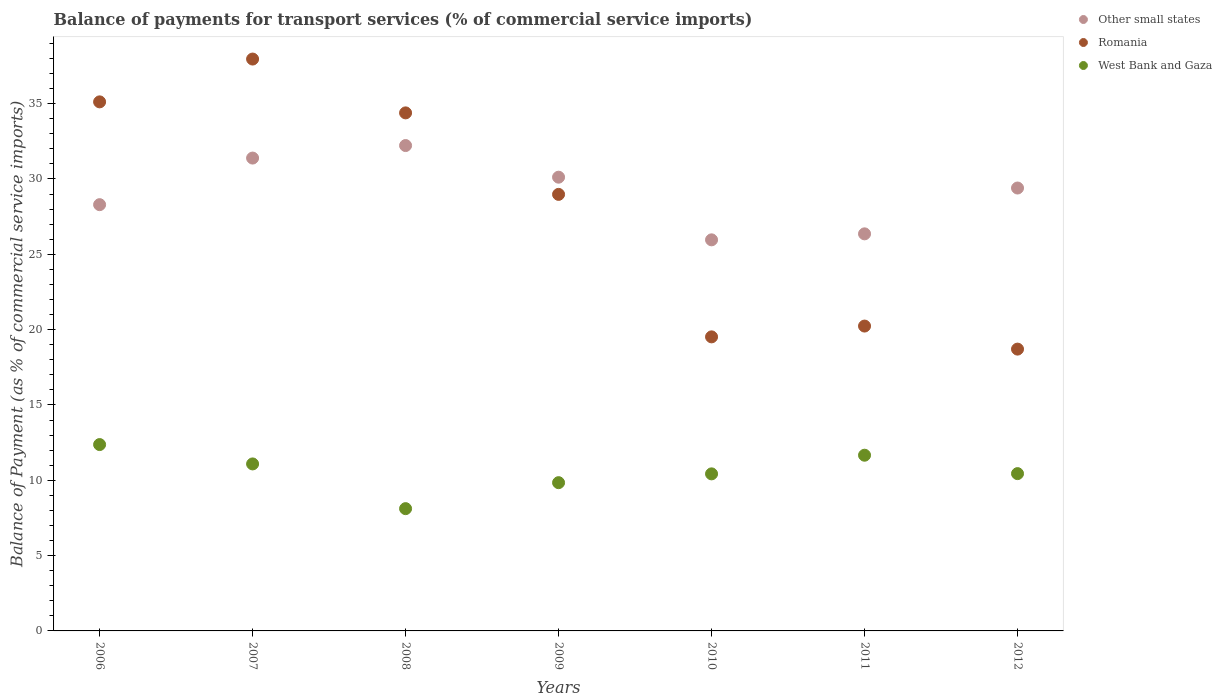How many different coloured dotlines are there?
Keep it short and to the point. 3. Is the number of dotlines equal to the number of legend labels?
Your answer should be very brief. Yes. What is the balance of payments for transport services in Other small states in 2010?
Offer a terse response. 25.96. Across all years, what is the maximum balance of payments for transport services in Romania?
Provide a short and direct response. 37.96. Across all years, what is the minimum balance of payments for transport services in West Bank and Gaza?
Offer a terse response. 8.12. In which year was the balance of payments for transport services in Other small states maximum?
Keep it short and to the point. 2008. What is the total balance of payments for transport services in West Bank and Gaza in the graph?
Give a very brief answer. 73.94. What is the difference between the balance of payments for transport services in Romania in 2007 and that in 2009?
Offer a terse response. 8.98. What is the difference between the balance of payments for transport services in Other small states in 2007 and the balance of payments for transport services in Romania in 2008?
Offer a very short reply. -3. What is the average balance of payments for transport services in West Bank and Gaza per year?
Give a very brief answer. 10.56. In the year 2010, what is the difference between the balance of payments for transport services in Other small states and balance of payments for transport services in West Bank and Gaza?
Your response must be concise. 15.53. In how many years, is the balance of payments for transport services in Romania greater than 9 %?
Your response must be concise. 7. What is the ratio of the balance of payments for transport services in West Bank and Gaza in 2007 to that in 2010?
Make the answer very short. 1.06. What is the difference between the highest and the second highest balance of payments for transport services in Other small states?
Provide a succinct answer. 0.83. What is the difference between the highest and the lowest balance of payments for transport services in Romania?
Ensure brevity in your answer.  19.25. In how many years, is the balance of payments for transport services in Romania greater than the average balance of payments for transport services in Romania taken over all years?
Your answer should be very brief. 4. Is it the case that in every year, the sum of the balance of payments for transport services in Other small states and balance of payments for transport services in West Bank and Gaza  is greater than the balance of payments for transport services in Romania?
Your response must be concise. Yes. Does the balance of payments for transport services in Other small states monotonically increase over the years?
Your answer should be very brief. No. How many dotlines are there?
Your response must be concise. 3. Does the graph contain any zero values?
Your answer should be very brief. No. What is the title of the graph?
Your answer should be compact. Balance of payments for transport services (% of commercial service imports). Does "Turkey" appear as one of the legend labels in the graph?
Provide a succinct answer. No. What is the label or title of the X-axis?
Keep it short and to the point. Years. What is the label or title of the Y-axis?
Make the answer very short. Balance of Payment (as % of commercial service imports). What is the Balance of Payment (as % of commercial service imports) of Other small states in 2006?
Offer a very short reply. 28.3. What is the Balance of Payment (as % of commercial service imports) of Romania in 2006?
Give a very brief answer. 35.12. What is the Balance of Payment (as % of commercial service imports) in West Bank and Gaza in 2006?
Your answer should be very brief. 12.37. What is the Balance of Payment (as % of commercial service imports) in Other small states in 2007?
Make the answer very short. 31.39. What is the Balance of Payment (as % of commercial service imports) in Romania in 2007?
Offer a terse response. 37.96. What is the Balance of Payment (as % of commercial service imports) of West Bank and Gaza in 2007?
Provide a short and direct response. 11.09. What is the Balance of Payment (as % of commercial service imports) of Other small states in 2008?
Your response must be concise. 32.22. What is the Balance of Payment (as % of commercial service imports) of Romania in 2008?
Keep it short and to the point. 34.39. What is the Balance of Payment (as % of commercial service imports) in West Bank and Gaza in 2008?
Your answer should be very brief. 8.12. What is the Balance of Payment (as % of commercial service imports) of Other small states in 2009?
Give a very brief answer. 30.12. What is the Balance of Payment (as % of commercial service imports) of Romania in 2009?
Your answer should be very brief. 28.98. What is the Balance of Payment (as % of commercial service imports) in West Bank and Gaza in 2009?
Give a very brief answer. 9.84. What is the Balance of Payment (as % of commercial service imports) of Other small states in 2010?
Keep it short and to the point. 25.96. What is the Balance of Payment (as % of commercial service imports) in Romania in 2010?
Offer a very short reply. 19.52. What is the Balance of Payment (as % of commercial service imports) of West Bank and Gaza in 2010?
Make the answer very short. 10.43. What is the Balance of Payment (as % of commercial service imports) in Other small states in 2011?
Provide a short and direct response. 26.36. What is the Balance of Payment (as % of commercial service imports) of Romania in 2011?
Offer a very short reply. 20.24. What is the Balance of Payment (as % of commercial service imports) in West Bank and Gaza in 2011?
Provide a succinct answer. 11.66. What is the Balance of Payment (as % of commercial service imports) of Other small states in 2012?
Your answer should be very brief. 29.4. What is the Balance of Payment (as % of commercial service imports) in Romania in 2012?
Keep it short and to the point. 18.71. What is the Balance of Payment (as % of commercial service imports) of West Bank and Gaza in 2012?
Offer a very short reply. 10.44. Across all years, what is the maximum Balance of Payment (as % of commercial service imports) of Other small states?
Offer a terse response. 32.22. Across all years, what is the maximum Balance of Payment (as % of commercial service imports) of Romania?
Provide a succinct answer. 37.96. Across all years, what is the maximum Balance of Payment (as % of commercial service imports) of West Bank and Gaza?
Keep it short and to the point. 12.37. Across all years, what is the minimum Balance of Payment (as % of commercial service imports) in Other small states?
Your response must be concise. 25.96. Across all years, what is the minimum Balance of Payment (as % of commercial service imports) in Romania?
Your answer should be very brief. 18.71. Across all years, what is the minimum Balance of Payment (as % of commercial service imports) of West Bank and Gaza?
Provide a succinct answer. 8.12. What is the total Balance of Payment (as % of commercial service imports) of Other small states in the graph?
Your answer should be compact. 203.74. What is the total Balance of Payment (as % of commercial service imports) of Romania in the graph?
Your answer should be very brief. 194.91. What is the total Balance of Payment (as % of commercial service imports) in West Bank and Gaza in the graph?
Ensure brevity in your answer.  73.94. What is the difference between the Balance of Payment (as % of commercial service imports) of Other small states in 2006 and that in 2007?
Ensure brevity in your answer.  -3.09. What is the difference between the Balance of Payment (as % of commercial service imports) of Romania in 2006 and that in 2007?
Make the answer very short. -2.84. What is the difference between the Balance of Payment (as % of commercial service imports) in West Bank and Gaza in 2006 and that in 2007?
Make the answer very short. 1.28. What is the difference between the Balance of Payment (as % of commercial service imports) in Other small states in 2006 and that in 2008?
Keep it short and to the point. -3.92. What is the difference between the Balance of Payment (as % of commercial service imports) of Romania in 2006 and that in 2008?
Offer a terse response. 0.73. What is the difference between the Balance of Payment (as % of commercial service imports) in West Bank and Gaza in 2006 and that in 2008?
Give a very brief answer. 4.25. What is the difference between the Balance of Payment (as % of commercial service imports) of Other small states in 2006 and that in 2009?
Provide a short and direct response. -1.82. What is the difference between the Balance of Payment (as % of commercial service imports) in Romania in 2006 and that in 2009?
Your answer should be very brief. 6.14. What is the difference between the Balance of Payment (as % of commercial service imports) of West Bank and Gaza in 2006 and that in 2009?
Your response must be concise. 2.53. What is the difference between the Balance of Payment (as % of commercial service imports) of Other small states in 2006 and that in 2010?
Offer a terse response. 2.34. What is the difference between the Balance of Payment (as % of commercial service imports) of Romania in 2006 and that in 2010?
Give a very brief answer. 15.6. What is the difference between the Balance of Payment (as % of commercial service imports) of West Bank and Gaza in 2006 and that in 2010?
Ensure brevity in your answer.  1.94. What is the difference between the Balance of Payment (as % of commercial service imports) of Other small states in 2006 and that in 2011?
Provide a short and direct response. 1.94. What is the difference between the Balance of Payment (as % of commercial service imports) in Romania in 2006 and that in 2011?
Ensure brevity in your answer.  14.88. What is the difference between the Balance of Payment (as % of commercial service imports) in West Bank and Gaza in 2006 and that in 2011?
Your response must be concise. 0.71. What is the difference between the Balance of Payment (as % of commercial service imports) in Other small states in 2006 and that in 2012?
Your response must be concise. -1.1. What is the difference between the Balance of Payment (as % of commercial service imports) in Romania in 2006 and that in 2012?
Give a very brief answer. 16.41. What is the difference between the Balance of Payment (as % of commercial service imports) in West Bank and Gaza in 2006 and that in 2012?
Offer a terse response. 1.93. What is the difference between the Balance of Payment (as % of commercial service imports) of Other small states in 2007 and that in 2008?
Ensure brevity in your answer.  -0.83. What is the difference between the Balance of Payment (as % of commercial service imports) in Romania in 2007 and that in 2008?
Your answer should be very brief. 3.57. What is the difference between the Balance of Payment (as % of commercial service imports) of West Bank and Gaza in 2007 and that in 2008?
Ensure brevity in your answer.  2.97. What is the difference between the Balance of Payment (as % of commercial service imports) in Other small states in 2007 and that in 2009?
Keep it short and to the point. 1.27. What is the difference between the Balance of Payment (as % of commercial service imports) in Romania in 2007 and that in 2009?
Offer a terse response. 8.98. What is the difference between the Balance of Payment (as % of commercial service imports) of West Bank and Gaza in 2007 and that in 2009?
Provide a succinct answer. 1.24. What is the difference between the Balance of Payment (as % of commercial service imports) of Other small states in 2007 and that in 2010?
Your answer should be very brief. 5.43. What is the difference between the Balance of Payment (as % of commercial service imports) in Romania in 2007 and that in 2010?
Provide a short and direct response. 18.44. What is the difference between the Balance of Payment (as % of commercial service imports) in West Bank and Gaza in 2007 and that in 2010?
Your answer should be compact. 0.66. What is the difference between the Balance of Payment (as % of commercial service imports) in Other small states in 2007 and that in 2011?
Ensure brevity in your answer.  5.03. What is the difference between the Balance of Payment (as % of commercial service imports) of Romania in 2007 and that in 2011?
Your answer should be compact. 17.72. What is the difference between the Balance of Payment (as % of commercial service imports) in West Bank and Gaza in 2007 and that in 2011?
Give a very brief answer. -0.58. What is the difference between the Balance of Payment (as % of commercial service imports) in Other small states in 2007 and that in 2012?
Ensure brevity in your answer.  1.99. What is the difference between the Balance of Payment (as % of commercial service imports) of Romania in 2007 and that in 2012?
Provide a succinct answer. 19.25. What is the difference between the Balance of Payment (as % of commercial service imports) of West Bank and Gaza in 2007 and that in 2012?
Provide a succinct answer. 0.64. What is the difference between the Balance of Payment (as % of commercial service imports) in Other small states in 2008 and that in 2009?
Make the answer very short. 2.1. What is the difference between the Balance of Payment (as % of commercial service imports) in Romania in 2008 and that in 2009?
Provide a short and direct response. 5.41. What is the difference between the Balance of Payment (as % of commercial service imports) of West Bank and Gaza in 2008 and that in 2009?
Your answer should be compact. -1.72. What is the difference between the Balance of Payment (as % of commercial service imports) of Other small states in 2008 and that in 2010?
Your response must be concise. 6.26. What is the difference between the Balance of Payment (as % of commercial service imports) of Romania in 2008 and that in 2010?
Keep it short and to the point. 14.87. What is the difference between the Balance of Payment (as % of commercial service imports) in West Bank and Gaza in 2008 and that in 2010?
Provide a succinct answer. -2.31. What is the difference between the Balance of Payment (as % of commercial service imports) of Other small states in 2008 and that in 2011?
Give a very brief answer. 5.86. What is the difference between the Balance of Payment (as % of commercial service imports) of Romania in 2008 and that in 2011?
Offer a terse response. 14.15. What is the difference between the Balance of Payment (as % of commercial service imports) of West Bank and Gaza in 2008 and that in 2011?
Make the answer very short. -3.55. What is the difference between the Balance of Payment (as % of commercial service imports) of Other small states in 2008 and that in 2012?
Give a very brief answer. 2.82. What is the difference between the Balance of Payment (as % of commercial service imports) in Romania in 2008 and that in 2012?
Your answer should be compact. 15.68. What is the difference between the Balance of Payment (as % of commercial service imports) of West Bank and Gaza in 2008 and that in 2012?
Your response must be concise. -2.32. What is the difference between the Balance of Payment (as % of commercial service imports) in Other small states in 2009 and that in 2010?
Ensure brevity in your answer.  4.16. What is the difference between the Balance of Payment (as % of commercial service imports) in Romania in 2009 and that in 2010?
Offer a very short reply. 9.46. What is the difference between the Balance of Payment (as % of commercial service imports) in West Bank and Gaza in 2009 and that in 2010?
Offer a very short reply. -0.58. What is the difference between the Balance of Payment (as % of commercial service imports) of Other small states in 2009 and that in 2011?
Keep it short and to the point. 3.76. What is the difference between the Balance of Payment (as % of commercial service imports) of Romania in 2009 and that in 2011?
Keep it short and to the point. 8.74. What is the difference between the Balance of Payment (as % of commercial service imports) of West Bank and Gaza in 2009 and that in 2011?
Offer a terse response. -1.82. What is the difference between the Balance of Payment (as % of commercial service imports) in Other small states in 2009 and that in 2012?
Ensure brevity in your answer.  0.72. What is the difference between the Balance of Payment (as % of commercial service imports) of Romania in 2009 and that in 2012?
Keep it short and to the point. 10.27. What is the difference between the Balance of Payment (as % of commercial service imports) of West Bank and Gaza in 2009 and that in 2012?
Keep it short and to the point. -0.6. What is the difference between the Balance of Payment (as % of commercial service imports) of Other small states in 2010 and that in 2011?
Give a very brief answer. -0.4. What is the difference between the Balance of Payment (as % of commercial service imports) of Romania in 2010 and that in 2011?
Provide a short and direct response. -0.72. What is the difference between the Balance of Payment (as % of commercial service imports) in West Bank and Gaza in 2010 and that in 2011?
Make the answer very short. -1.24. What is the difference between the Balance of Payment (as % of commercial service imports) of Other small states in 2010 and that in 2012?
Give a very brief answer. -3.44. What is the difference between the Balance of Payment (as % of commercial service imports) of Romania in 2010 and that in 2012?
Provide a short and direct response. 0.81. What is the difference between the Balance of Payment (as % of commercial service imports) in West Bank and Gaza in 2010 and that in 2012?
Keep it short and to the point. -0.02. What is the difference between the Balance of Payment (as % of commercial service imports) in Other small states in 2011 and that in 2012?
Provide a short and direct response. -3.04. What is the difference between the Balance of Payment (as % of commercial service imports) in Romania in 2011 and that in 2012?
Offer a very short reply. 1.53. What is the difference between the Balance of Payment (as % of commercial service imports) of West Bank and Gaza in 2011 and that in 2012?
Provide a short and direct response. 1.22. What is the difference between the Balance of Payment (as % of commercial service imports) in Other small states in 2006 and the Balance of Payment (as % of commercial service imports) in Romania in 2007?
Your response must be concise. -9.67. What is the difference between the Balance of Payment (as % of commercial service imports) in Other small states in 2006 and the Balance of Payment (as % of commercial service imports) in West Bank and Gaza in 2007?
Provide a succinct answer. 17.21. What is the difference between the Balance of Payment (as % of commercial service imports) of Romania in 2006 and the Balance of Payment (as % of commercial service imports) of West Bank and Gaza in 2007?
Offer a very short reply. 24.03. What is the difference between the Balance of Payment (as % of commercial service imports) in Other small states in 2006 and the Balance of Payment (as % of commercial service imports) in Romania in 2008?
Give a very brief answer. -6.09. What is the difference between the Balance of Payment (as % of commercial service imports) in Other small states in 2006 and the Balance of Payment (as % of commercial service imports) in West Bank and Gaza in 2008?
Provide a short and direct response. 20.18. What is the difference between the Balance of Payment (as % of commercial service imports) of Romania in 2006 and the Balance of Payment (as % of commercial service imports) of West Bank and Gaza in 2008?
Your answer should be compact. 27. What is the difference between the Balance of Payment (as % of commercial service imports) of Other small states in 2006 and the Balance of Payment (as % of commercial service imports) of Romania in 2009?
Keep it short and to the point. -0.68. What is the difference between the Balance of Payment (as % of commercial service imports) in Other small states in 2006 and the Balance of Payment (as % of commercial service imports) in West Bank and Gaza in 2009?
Keep it short and to the point. 18.45. What is the difference between the Balance of Payment (as % of commercial service imports) in Romania in 2006 and the Balance of Payment (as % of commercial service imports) in West Bank and Gaza in 2009?
Your answer should be very brief. 25.28. What is the difference between the Balance of Payment (as % of commercial service imports) of Other small states in 2006 and the Balance of Payment (as % of commercial service imports) of Romania in 2010?
Your answer should be compact. 8.78. What is the difference between the Balance of Payment (as % of commercial service imports) in Other small states in 2006 and the Balance of Payment (as % of commercial service imports) in West Bank and Gaza in 2010?
Your answer should be very brief. 17.87. What is the difference between the Balance of Payment (as % of commercial service imports) of Romania in 2006 and the Balance of Payment (as % of commercial service imports) of West Bank and Gaza in 2010?
Your answer should be very brief. 24.69. What is the difference between the Balance of Payment (as % of commercial service imports) of Other small states in 2006 and the Balance of Payment (as % of commercial service imports) of Romania in 2011?
Your response must be concise. 8.06. What is the difference between the Balance of Payment (as % of commercial service imports) in Other small states in 2006 and the Balance of Payment (as % of commercial service imports) in West Bank and Gaza in 2011?
Your answer should be very brief. 16.63. What is the difference between the Balance of Payment (as % of commercial service imports) in Romania in 2006 and the Balance of Payment (as % of commercial service imports) in West Bank and Gaza in 2011?
Make the answer very short. 23.46. What is the difference between the Balance of Payment (as % of commercial service imports) of Other small states in 2006 and the Balance of Payment (as % of commercial service imports) of Romania in 2012?
Keep it short and to the point. 9.59. What is the difference between the Balance of Payment (as % of commercial service imports) in Other small states in 2006 and the Balance of Payment (as % of commercial service imports) in West Bank and Gaza in 2012?
Make the answer very short. 17.85. What is the difference between the Balance of Payment (as % of commercial service imports) of Romania in 2006 and the Balance of Payment (as % of commercial service imports) of West Bank and Gaza in 2012?
Make the answer very short. 24.68. What is the difference between the Balance of Payment (as % of commercial service imports) in Other small states in 2007 and the Balance of Payment (as % of commercial service imports) in Romania in 2008?
Give a very brief answer. -3. What is the difference between the Balance of Payment (as % of commercial service imports) of Other small states in 2007 and the Balance of Payment (as % of commercial service imports) of West Bank and Gaza in 2008?
Provide a succinct answer. 23.27. What is the difference between the Balance of Payment (as % of commercial service imports) of Romania in 2007 and the Balance of Payment (as % of commercial service imports) of West Bank and Gaza in 2008?
Your answer should be compact. 29.84. What is the difference between the Balance of Payment (as % of commercial service imports) in Other small states in 2007 and the Balance of Payment (as % of commercial service imports) in Romania in 2009?
Ensure brevity in your answer.  2.41. What is the difference between the Balance of Payment (as % of commercial service imports) of Other small states in 2007 and the Balance of Payment (as % of commercial service imports) of West Bank and Gaza in 2009?
Give a very brief answer. 21.55. What is the difference between the Balance of Payment (as % of commercial service imports) in Romania in 2007 and the Balance of Payment (as % of commercial service imports) in West Bank and Gaza in 2009?
Offer a very short reply. 28.12. What is the difference between the Balance of Payment (as % of commercial service imports) of Other small states in 2007 and the Balance of Payment (as % of commercial service imports) of Romania in 2010?
Your response must be concise. 11.87. What is the difference between the Balance of Payment (as % of commercial service imports) in Other small states in 2007 and the Balance of Payment (as % of commercial service imports) in West Bank and Gaza in 2010?
Make the answer very short. 20.96. What is the difference between the Balance of Payment (as % of commercial service imports) in Romania in 2007 and the Balance of Payment (as % of commercial service imports) in West Bank and Gaza in 2010?
Provide a succinct answer. 27.54. What is the difference between the Balance of Payment (as % of commercial service imports) in Other small states in 2007 and the Balance of Payment (as % of commercial service imports) in Romania in 2011?
Ensure brevity in your answer.  11.15. What is the difference between the Balance of Payment (as % of commercial service imports) of Other small states in 2007 and the Balance of Payment (as % of commercial service imports) of West Bank and Gaza in 2011?
Your response must be concise. 19.72. What is the difference between the Balance of Payment (as % of commercial service imports) in Romania in 2007 and the Balance of Payment (as % of commercial service imports) in West Bank and Gaza in 2011?
Offer a very short reply. 26.3. What is the difference between the Balance of Payment (as % of commercial service imports) in Other small states in 2007 and the Balance of Payment (as % of commercial service imports) in Romania in 2012?
Ensure brevity in your answer.  12.68. What is the difference between the Balance of Payment (as % of commercial service imports) of Other small states in 2007 and the Balance of Payment (as % of commercial service imports) of West Bank and Gaza in 2012?
Your response must be concise. 20.95. What is the difference between the Balance of Payment (as % of commercial service imports) in Romania in 2007 and the Balance of Payment (as % of commercial service imports) in West Bank and Gaza in 2012?
Offer a terse response. 27.52. What is the difference between the Balance of Payment (as % of commercial service imports) in Other small states in 2008 and the Balance of Payment (as % of commercial service imports) in Romania in 2009?
Provide a short and direct response. 3.24. What is the difference between the Balance of Payment (as % of commercial service imports) of Other small states in 2008 and the Balance of Payment (as % of commercial service imports) of West Bank and Gaza in 2009?
Provide a succinct answer. 22.38. What is the difference between the Balance of Payment (as % of commercial service imports) of Romania in 2008 and the Balance of Payment (as % of commercial service imports) of West Bank and Gaza in 2009?
Provide a short and direct response. 24.55. What is the difference between the Balance of Payment (as % of commercial service imports) of Other small states in 2008 and the Balance of Payment (as % of commercial service imports) of Romania in 2010?
Your answer should be compact. 12.7. What is the difference between the Balance of Payment (as % of commercial service imports) in Other small states in 2008 and the Balance of Payment (as % of commercial service imports) in West Bank and Gaza in 2010?
Offer a very short reply. 21.79. What is the difference between the Balance of Payment (as % of commercial service imports) in Romania in 2008 and the Balance of Payment (as % of commercial service imports) in West Bank and Gaza in 2010?
Offer a terse response. 23.96. What is the difference between the Balance of Payment (as % of commercial service imports) of Other small states in 2008 and the Balance of Payment (as % of commercial service imports) of Romania in 2011?
Your answer should be very brief. 11.98. What is the difference between the Balance of Payment (as % of commercial service imports) in Other small states in 2008 and the Balance of Payment (as % of commercial service imports) in West Bank and Gaza in 2011?
Offer a terse response. 20.56. What is the difference between the Balance of Payment (as % of commercial service imports) of Romania in 2008 and the Balance of Payment (as % of commercial service imports) of West Bank and Gaza in 2011?
Your answer should be very brief. 22.72. What is the difference between the Balance of Payment (as % of commercial service imports) in Other small states in 2008 and the Balance of Payment (as % of commercial service imports) in Romania in 2012?
Provide a succinct answer. 13.51. What is the difference between the Balance of Payment (as % of commercial service imports) of Other small states in 2008 and the Balance of Payment (as % of commercial service imports) of West Bank and Gaza in 2012?
Your answer should be compact. 21.78. What is the difference between the Balance of Payment (as % of commercial service imports) of Romania in 2008 and the Balance of Payment (as % of commercial service imports) of West Bank and Gaza in 2012?
Your answer should be very brief. 23.95. What is the difference between the Balance of Payment (as % of commercial service imports) of Other small states in 2009 and the Balance of Payment (as % of commercial service imports) of Romania in 2010?
Your answer should be very brief. 10.6. What is the difference between the Balance of Payment (as % of commercial service imports) of Other small states in 2009 and the Balance of Payment (as % of commercial service imports) of West Bank and Gaza in 2010?
Ensure brevity in your answer.  19.69. What is the difference between the Balance of Payment (as % of commercial service imports) of Romania in 2009 and the Balance of Payment (as % of commercial service imports) of West Bank and Gaza in 2010?
Your answer should be compact. 18.55. What is the difference between the Balance of Payment (as % of commercial service imports) of Other small states in 2009 and the Balance of Payment (as % of commercial service imports) of Romania in 2011?
Your response must be concise. 9.88. What is the difference between the Balance of Payment (as % of commercial service imports) of Other small states in 2009 and the Balance of Payment (as % of commercial service imports) of West Bank and Gaza in 2011?
Your answer should be very brief. 18.46. What is the difference between the Balance of Payment (as % of commercial service imports) in Romania in 2009 and the Balance of Payment (as % of commercial service imports) in West Bank and Gaza in 2011?
Ensure brevity in your answer.  17.31. What is the difference between the Balance of Payment (as % of commercial service imports) in Other small states in 2009 and the Balance of Payment (as % of commercial service imports) in Romania in 2012?
Give a very brief answer. 11.41. What is the difference between the Balance of Payment (as % of commercial service imports) in Other small states in 2009 and the Balance of Payment (as % of commercial service imports) in West Bank and Gaza in 2012?
Your answer should be compact. 19.68. What is the difference between the Balance of Payment (as % of commercial service imports) of Romania in 2009 and the Balance of Payment (as % of commercial service imports) of West Bank and Gaza in 2012?
Provide a short and direct response. 18.54. What is the difference between the Balance of Payment (as % of commercial service imports) in Other small states in 2010 and the Balance of Payment (as % of commercial service imports) in Romania in 2011?
Keep it short and to the point. 5.72. What is the difference between the Balance of Payment (as % of commercial service imports) in Other small states in 2010 and the Balance of Payment (as % of commercial service imports) in West Bank and Gaza in 2011?
Keep it short and to the point. 14.3. What is the difference between the Balance of Payment (as % of commercial service imports) of Romania in 2010 and the Balance of Payment (as % of commercial service imports) of West Bank and Gaza in 2011?
Ensure brevity in your answer.  7.86. What is the difference between the Balance of Payment (as % of commercial service imports) in Other small states in 2010 and the Balance of Payment (as % of commercial service imports) in Romania in 2012?
Your response must be concise. 7.25. What is the difference between the Balance of Payment (as % of commercial service imports) of Other small states in 2010 and the Balance of Payment (as % of commercial service imports) of West Bank and Gaza in 2012?
Offer a very short reply. 15.52. What is the difference between the Balance of Payment (as % of commercial service imports) of Romania in 2010 and the Balance of Payment (as % of commercial service imports) of West Bank and Gaza in 2012?
Provide a short and direct response. 9.08. What is the difference between the Balance of Payment (as % of commercial service imports) in Other small states in 2011 and the Balance of Payment (as % of commercial service imports) in Romania in 2012?
Ensure brevity in your answer.  7.65. What is the difference between the Balance of Payment (as % of commercial service imports) of Other small states in 2011 and the Balance of Payment (as % of commercial service imports) of West Bank and Gaza in 2012?
Provide a short and direct response. 15.92. What is the difference between the Balance of Payment (as % of commercial service imports) of Romania in 2011 and the Balance of Payment (as % of commercial service imports) of West Bank and Gaza in 2012?
Your response must be concise. 9.79. What is the average Balance of Payment (as % of commercial service imports) of Other small states per year?
Your answer should be compact. 29.11. What is the average Balance of Payment (as % of commercial service imports) of Romania per year?
Provide a succinct answer. 27.84. What is the average Balance of Payment (as % of commercial service imports) of West Bank and Gaza per year?
Your answer should be very brief. 10.56. In the year 2006, what is the difference between the Balance of Payment (as % of commercial service imports) of Other small states and Balance of Payment (as % of commercial service imports) of Romania?
Offer a terse response. -6.82. In the year 2006, what is the difference between the Balance of Payment (as % of commercial service imports) of Other small states and Balance of Payment (as % of commercial service imports) of West Bank and Gaza?
Ensure brevity in your answer.  15.93. In the year 2006, what is the difference between the Balance of Payment (as % of commercial service imports) in Romania and Balance of Payment (as % of commercial service imports) in West Bank and Gaza?
Keep it short and to the point. 22.75. In the year 2007, what is the difference between the Balance of Payment (as % of commercial service imports) in Other small states and Balance of Payment (as % of commercial service imports) in Romania?
Your answer should be compact. -6.57. In the year 2007, what is the difference between the Balance of Payment (as % of commercial service imports) in Other small states and Balance of Payment (as % of commercial service imports) in West Bank and Gaza?
Ensure brevity in your answer.  20.3. In the year 2007, what is the difference between the Balance of Payment (as % of commercial service imports) in Romania and Balance of Payment (as % of commercial service imports) in West Bank and Gaza?
Provide a succinct answer. 26.88. In the year 2008, what is the difference between the Balance of Payment (as % of commercial service imports) of Other small states and Balance of Payment (as % of commercial service imports) of Romania?
Your answer should be very brief. -2.17. In the year 2008, what is the difference between the Balance of Payment (as % of commercial service imports) of Other small states and Balance of Payment (as % of commercial service imports) of West Bank and Gaza?
Your answer should be compact. 24.1. In the year 2008, what is the difference between the Balance of Payment (as % of commercial service imports) of Romania and Balance of Payment (as % of commercial service imports) of West Bank and Gaza?
Give a very brief answer. 26.27. In the year 2009, what is the difference between the Balance of Payment (as % of commercial service imports) of Other small states and Balance of Payment (as % of commercial service imports) of Romania?
Your answer should be very brief. 1.14. In the year 2009, what is the difference between the Balance of Payment (as % of commercial service imports) in Other small states and Balance of Payment (as % of commercial service imports) in West Bank and Gaza?
Provide a succinct answer. 20.28. In the year 2009, what is the difference between the Balance of Payment (as % of commercial service imports) in Romania and Balance of Payment (as % of commercial service imports) in West Bank and Gaza?
Provide a succinct answer. 19.14. In the year 2010, what is the difference between the Balance of Payment (as % of commercial service imports) in Other small states and Balance of Payment (as % of commercial service imports) in Romania?
Give a very brief answer. 6.44. In the year 2010, what is the difference between the Balance of Payment (as % of commercial service imports) in Other small states and Balance of Payment (as % of commercial service imports) in West Bank and Gaza?
Make the answer very short. 15.53. In the year 2010, what is the difference between the Balance of Payment (as % of commercial service imports) in Romania and Balance of Payment (as % of commercial service imports) in West Bank and Gaza?
Your answer should be very brief. 9.09. In the year 2011, what is the difference between the Balance of Payment (as % of commercial service imports) of Other small states and Balance of Payment (as % of commercial service imports) of Romania?
Make the answer very short. 6.12. In the year 2011, what is the difference between the Balance of Payment (as % of commercial service imports) of Other small states and Balance of Payment (as % of commercial service imports) of West Bank and Gaza?
Your answer should be compact. 14.69. In the year 2011, what is the difference between the Balance of Payment (as % of commercial service imports) of Romania and Balance of Payment (as % of commercial service imports) of West Bank and Gaza?
Your answer should be compact. 8.57. In the year 2012, what is the difference between the Balance of Payment (as % of commercial service imports) of Other small states and Balance of Payment (as % of commercial service imports) of Romania?
Offer a terse response. 10.69. In the year 2012, what is the difference between the Balance of Payment (as % of commercial service imports) in Other small states and Balance of Payment (as % of commercial service imports) in West Bank and Gaza?
Your answer should be very brief. 18.96. In the year 2012, what is the difference between the Balance of Payment (as % of commercial service imports) of Romania and Balance of Payment (as % of commercial service imports) of West Bank and Gaza?
Give a very brief answer. 8.27. What is the ratio of the Balance of Payment (as % of commercial service imports) of Other small states in 2006 to that in 2007?
Provide a succinct answer. 0.9. What is the ratio of the Balance of Payment (as % of commercial service imports) of Romania in 2006 to that in 2007?
Your response must be concise. 0.93. What is the ratio of the Balance of Payment (as % of commercial service imports) of West Bank and Gaza in 2006 to that in 2007?
Provide a short and direct response. 1.12. What is the ratio of the Balance of Payment (as % of commercial service imports) of Other small states in 2006 to that in 2008?
Your answer should be compact. 0.88. What is the ratio of the Balance of Payment (as % of commercial service imports) of Romania in 2006 to that in 2008?
Your response must be concise. 1.02. What is the ratio of the Balance of Payment (as % of commercial service imports) of West Bank and Gaza in 2006 to that in 2008?
Offer a terse response. 1.52. What is the ratio of the Balance of Payment (as % of commercial service imports) of Other small states in 2006 to that in 2009?
Provide a short and direct response. 0.94. What is the ratio of the Balance of Payment (as % of commercial service imports) of Romania in 2006 to that in 2009?
Your answer should be compact. 1.21. What is the ratio of the Balance of Payment (as % of commercial service imports) in West Bank and Gaza in 2006 to that in 2009?
Your response must be concise. 1.26. What is the ratio of the Balance of Payment (as % of commercial service imports) of Other small states in 2006 to that in 2010?
Your response must be concise. 1.09. What is the ratio of the Balance of Payment (as % of commercial service imports) in Romania in 2006 to that in 2010?
Your answer should be very brief. 1.8. What is the ratio of the Balance of Payment (as % of commercial service imports) of West Bank and Gaza in 2006 to that in 2010?
Your response must be concise. 1.19. What is the ratio of the Balance of Payment (as % of commercial service imports) in Other small states in 2006 to that in 2011?
Your response must be concise. 1.07. What is the ratio of the Balance of Payment (as % of commercial service imports) in Romania in 2006 to that in 2011?
Give a very brief answer. 1.74. What is the ratio of the Balance of Payment (as % of commercial service imports) in West Bank and Gaza in 2006 to that in 2011?
Give a very brief answer. 1.06. What is the ratio of the Balance of Payment (as % of commercial service imports) of Other small states in 2006 to that in 2012?
Provide a succinct answer. 0.96. What is the ratio of the Balance of Payment (as % of commercial service imports) of Romania in 2006 to that in 2012?
Give a very brief answer. 1.88. What is the ratio of the Balance of Payment (as % of commercial service imports) in West Bank and Gaza in 2006 to that in 2012?
Provide a short and direct response. 1.18. What is the ratio of the Balance of Payment (as % of commercial service imports) in Other small states in 2007 to that in 2008?
Your answer should be compact. 0.97. What is the ratio of the Balance of Payment (as % of commercial service imports) in Romania in 2007 to that in 2008?
Give a very brief answer. 1.1. What is the ratio of the Balance of Payment (as % of commercial service imports) in West Bank and Gaza in 2007 to that in 2008?
Make the answer very short. 1.37. What is the ratio of the Balance of Payment (as % of commercial service imports) of Other small states in 2007 to that in 2009?
Offer a very short reply. 1.04. What is the ratio of the Balance of Payment (as % of commercial service imports) in Romania in 2007 to that in 2009?
Provide a succinct answer. 1.31. What is the ratio of the Balance of Payment (as % of commercial service imports) in West Bank and Gaza in 2007 to that in 2009?
Your response must be concise. 1.13. What is the ratio of the Balance of Payment (as % of commercial service imports) of Other small states in 2007 to that in 2010?
Your answer should be very brief. 1.21. What is the ratio of the Balance of Payment (as % of commercial service imports) in Romania in 2007 to that in 2010?
Your response must be concise. 1.94. What is the ratio of the Balance of Payment (as % of commercial service imports) in West Bank and Gaza in 2007 to that in 2010?
Your answer should be very brief. 1.06. What is the ratio of the Balance of Payment (as % of commercial service imports) of Other small states in 2007 to that in 2011?
Give a very brief answer. 1.19. What is the ratio of the Balance of Payment (as % of commercial service imports) in Romania in 2007 to that in 2011?
Keep it short and to the point. 1.88. What is the ratio of the Balance of Payment (as % of commercial service imports) of West Bank and Gaza in 2007 to that in 2011?
Make the answer very short. 0.95. What is the ratio of the Balance of Payment (as % of commercial service imports) of Other small states in 2007 to that in 2012?
Offer a terse response. 1.07. What is the ratio of the Balance of Payment (as % of commercial service imports) in Romania in 2007 to that in 2012?
Ensure brevity in your answer.  2.03. What is the ratio of the Balance of Payment (as % of commercial service imports) of West Bank and Gaza in 2007 to that in 2012?
Give a very brief answer. 1.06. What is the ratio of the Balance of Payment (as % of commercial service imports) in Other small states in 2008 to that in 2009?
Provide a succinct answer. 1.07. What is the ratio of the Balance of Payment (as % of commercial service imports) of Romania in 2008 to that in 2009?
Ensure brevity in your answer.  1.19. What is the ratio of the Balance of Payment (as % of commercial service imports) in West Bank and Gaza in 2008 to that in 2009?
Make the answer very short. 0.82. What is the ratio of the Balance of Payment (as % of commercial service imports) of Other small states in 2008 to that in 2010?
Provide a succinct answer. 1.24. What is the ratio of the Balance of Payment (as % of commercial service imports) of Romania in 2008 to that in 2010?
Keep it short and to the point. 1.76. What is the ratio of the Balance of Payment (as % of commercial service imports) in West Bank and Gaza in 2008 to that in 2010?
Keep it short and to the point. 0.78. What is the ratio of the Balance of Payment (as % of commercial service imports) in Other small states in 2008 to that in 2011?
Give a very brief answer. 1.22. What is the ratio of the Balance of Payment (as % of commercial service imports) of Romania in 2008 to that in 2011?
Make the answer very short. 1.7. What is the ratio of the Balance of Payment (as % of commercial service imports) of West Bank and Gaza in 2008 to that in 2011?
Your answer should be very brief. 0.7. What is the ratio of the Balance of Payment (as % of commercial service imports) in Other small states in 2008 to that in 2012?
Provide a short and direct response. 1.1. What is the ratio of the Balance of Payment (as % of commercial service imports) in Romania in 2008 to that in 2012?
Make the answer very short. 1.84. What is the ratio of the Balance of Payment (as % of commercial service imports) in West Bank and Gaza in 2008 to that in 2012?
Offer a terse response. 0.78. What is the ratio of the Balance of Payment (as % of commercial service imports) in Other small states in 2009 to that in 2010?
Your answer should be very brief. 1.16. What is the ratio of the Balance of Payment (as % of commercial service imports) in Romania in 2009 to that in 2010?
Your answer should be very brief. 1.48. What is the ratio of the Balance of Payment (as % of commercial service imports) in West Bank and Gaza in 2009 to that in 2010?
Ensure brevity in your answer.  0.94. What is the ratio of the Balance of Payment (as % of commercial service imports) of Other small states in 2009 to that in 2011?
Provide a succinct answer. 1.14. What is the ratio of the Balance of Payment (as % of commercial service imports) in Romania in 2009 to that in 2011?
Provide a short and direct response. 1.43. What is the ratio of the Balance of Payment (as % of commercial service imports) of West Bank and Gaza in 2009 to that in 2011?
Your response must be concise. 0.84. What is the ratio of the Balance of Payment (as % of commercial service imports) in Other small states in 2009 to that in 2012?
Ensure brevity in your answer.  1.02. What is the ratio of the Balance of Payment (as % of commercial service imports) in Romania in 2009 to that in 2012?
Ensure brevity in your answer.  1.55. What is the ratio of the Balance of Payment (as % of commercial service imports) in West Bank and Gaza in 2009 to that in 2012?
Offer a terse response. 0.94. What is the ratio of the Balance of Payment (as % of commercial service imports) in Other small states in 2010 to that in 2011?
Keep it short and to the point. 0.98. What is the ratio of the Balance of Payment (as % of commercial service imports) in Romania in 2010 to that in 2011?
Offer a terse response. 0.96. What is the ratio of the Balance of Payment (as % of commercial service imports) in West Bank and Gaza in 2010 to that in 2011?
Keep it short and to the point. 0.89. What is the ratio of the Balance of Payment (as % of commercial service imports) in Other small states in 2010 to that in 2012?
Keep it short and to the point. 0.88. What is the ratio of the Balance of Payment (as % of commercial service imports) in Romania in 2010 to that in 2012?
Give a very brief answer. 1.04. What is the ratio of the Balance of Payment (as % of commercial service imports) in Other small states in 2011 to that in 2012?
Provide a succinct answer. 0.9. What is the ratio of the Balance of Payment (as % of commercial service imports) in Romania in 2011 to that in 2012?
Provide a succinct answer. 1.08. What is the ratio of the Balance of Payment (as % of commercial service imports) of West Bank and Gaza in 2011 to that in 2012?
Provide a short and direct response. 1.12. What is the difference between the highest and the second highest Balance of Payment (as % of commercial service imports) in Other small states?
Make the answer very short. 0.83. What is the difference between the highest and the second highest Balance of Payment (as % of commercial service imports) of Romania?
Offer a very short reply. 2.84. What is the difference between the highest and the second highest Balance of Payment (as % of commercial service imports) of West Bank and Gaza?
Provide a short and direct response. 0.71. What is the difference between the highest and the lowest Balance of Payment (as % of commercial service imports) in Other small states?
Make the answer very short. 6.26. What is the difference between the highest and the lowest Balance of Payment (as % of commercial service imports) in Romania?
Your response must be concise. 19.25. What is the difference between the highest and the lowest Balance of Payment (as % of commercial service imports) of West Bank and Gaza?
Ensure brevity in your answer.  4.25. 